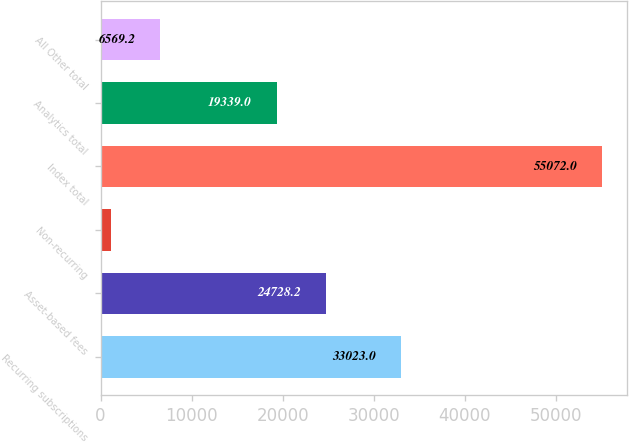Convert chart. <chart><loc_0><loc_0><loc_500><loc_500><bar_chart><fcel>Recurring subscriptions<fcel>Asset-based fees<fcel>Non-recurring<fcel>Index total<fcel>Analytics total<fcel>All Other total<nl><fcel>33023<fcel>24728.2<fcel>1180<fcel>55072<fcel>19339<fcel>6569.2<nl></chart> 